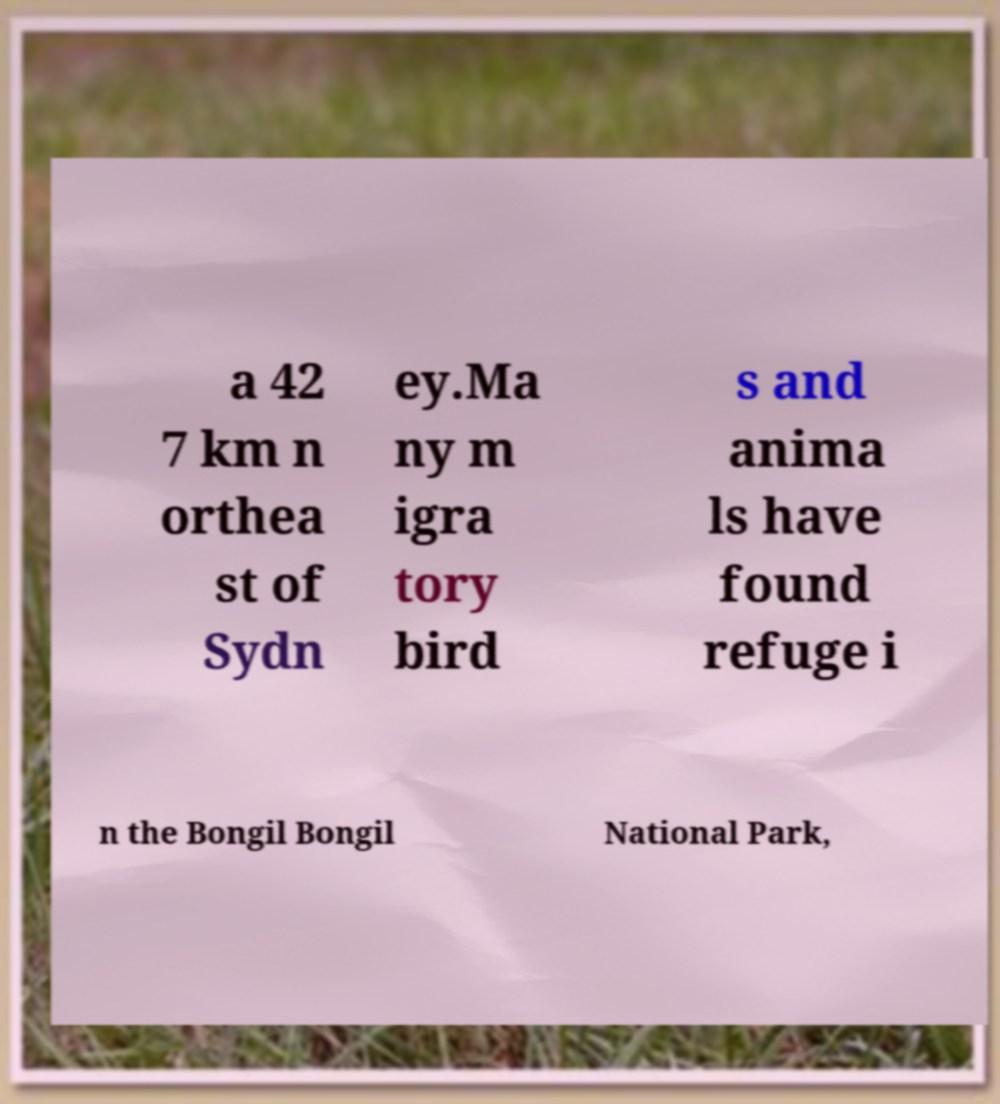I need the written content from this picture converted into text. Can you do that? a 42 7 km n orthea st of Sydn ey.Ma ny m igra tory bird s and anima ls have found refuge i n the Bongil Bongil National Park, 